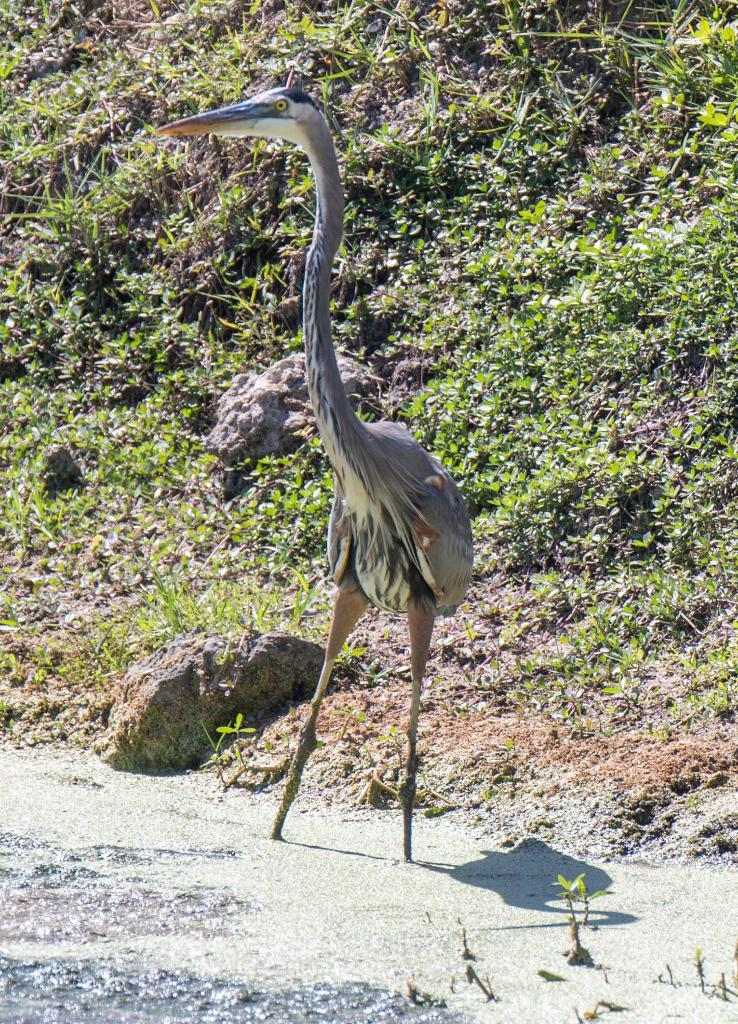What type of animal can be seen in the image? There is a bird in the image. What can be seen in the background of the image? There are plants and stones in the background of the image. What type of polish is the bird using to clean its feathers in the image? There is no indication in the image that the bird is using any polish to clean its feathers. 